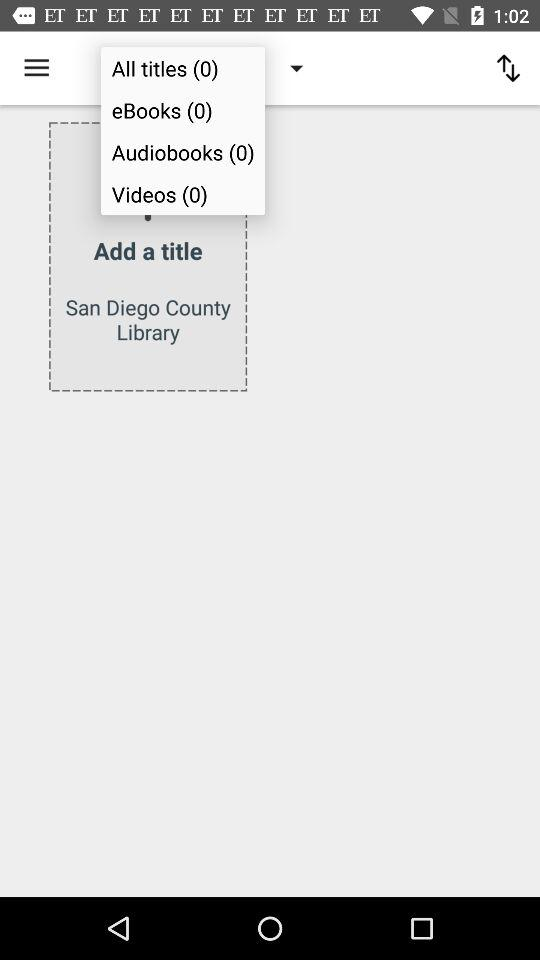How many ebooks are there? There are 0 ebooks. 